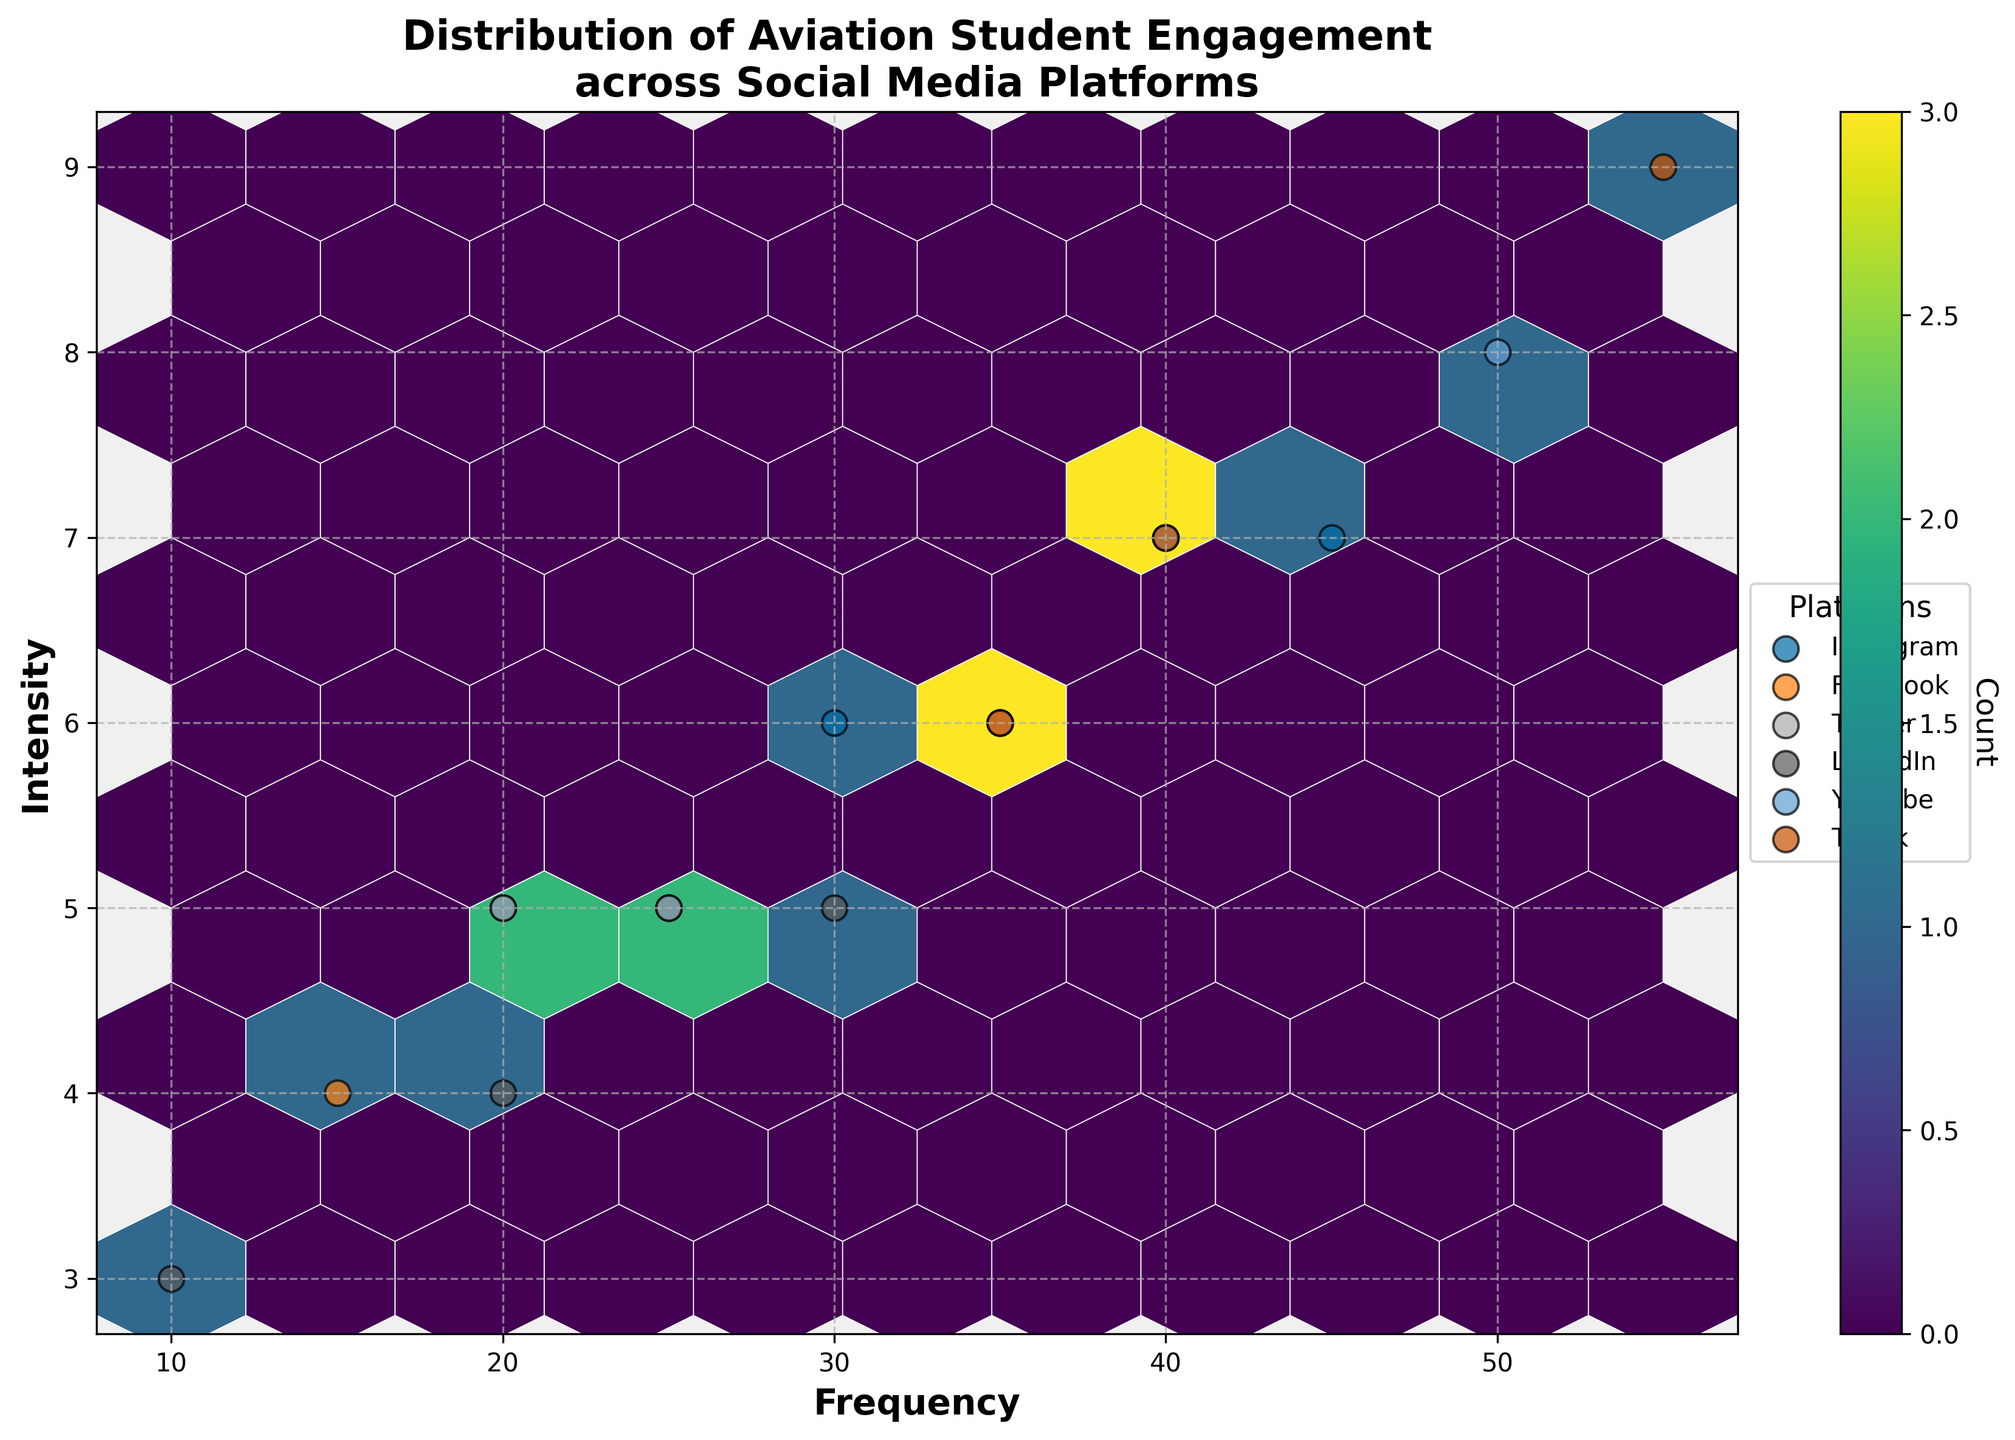What is the title of the plot? The title is positioned at the top of the plot, it reads "Distribution of Aviation Student Engagement across Social Media Platforms”. This helps set the context for the hexbin plot.
Answer: Distribution of Aviation Student Engagement across Social Media Platforms What do the colors represent in the hexbin plot? The colors in the hexbin plot represent varying counts of data points within each hexagonal bin. The color bar on the right side of the plot shows the gradient and values.
Answer: Count Which platform shows the highest frequency and intensity of engagement? Looking at the scatter points representing each platform, TikTok's engagement type ‘Likes’ is at (55, 9), which is the highest frequency and intensity among all platforms visible on the plot.
Answer: TikTok How does YouTube's engagement compare to Instagram’s in terms of frequency and intensity? By locating the YouTube and Instagram data points, YouTube’s highest data point for 'Views' is (50, 8) while Instagram’s highest for 'Likes' is (45, 7). Therefore, YouTube shows higher frequency and intensity compared to Instagram.
Answer: YouTube shows higher What is the frequency range represented in the plot? The frequency axis ranges from about 0 to just over 55. This is derived from examining the x-axis, which represents frequency.
Answer: 0 to just over 55 Which engagement type has the highest intensity on Twitter? On the plot, Twitter's engagement type ‘Likes’ has the frequency 40 and an intensity of 7, making it the highest intensity among Twitter’s points.
Answer: Likes What is the average intensity for Facebook’s engagement types? For Facebook, the intensities are 6 (Likes), 5 (Comments), and 4 (Shares). Summing these (6 + 5 + 4 = 15) and dividing by the number of engagement types (3) gives an average intensity of 15/3 = 5.
Answer: 5 How does the distribution of engagement for LinkedIn compare to that of YouTube? LinkedIn has lower frequency and intensity values compared to YouTube. For LinkedIn: 'Likes' at (30, 5), 'Comments' at (20, 4), and 'Shares' at (10, 3). For YouTube: 'Views' at (50, 8), 'Likes' at (40, 7), and 'Comments' at (25, 5). This indicates YouTube generally has higher engagement.
Answer: YouTube has higher engagement How many unique platforms are represented in the plot? By examining the legend on the right hand side and the scatter points, we deduce there are six platforms (Instagram, Facebook, Twitter, LinkedIn, YouTube, TikTok).
Answer: Six What can you infer from the differing colors in the hexbin cells? The varying shades of color across hexbin cells indicate different concentrations of overlapping data points, with deeper colors representing higher concentrations. This helps identify areas of higher density in student engagement.
Answer: Different concentrations of data points 